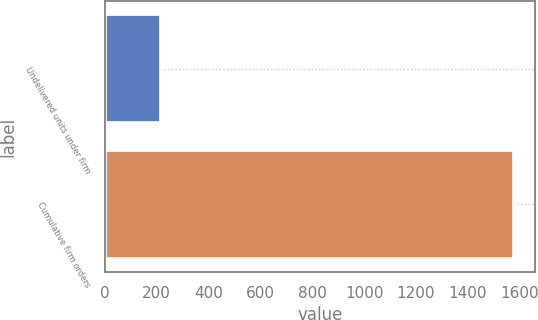<chart> <loc_0><loc_0><loc_500><loc_500><bar_chart><fcel>Undelivered units under firm<fcel>Cumulative firm orders<nl><fcel>218<fcel>1579<nl></chart> 